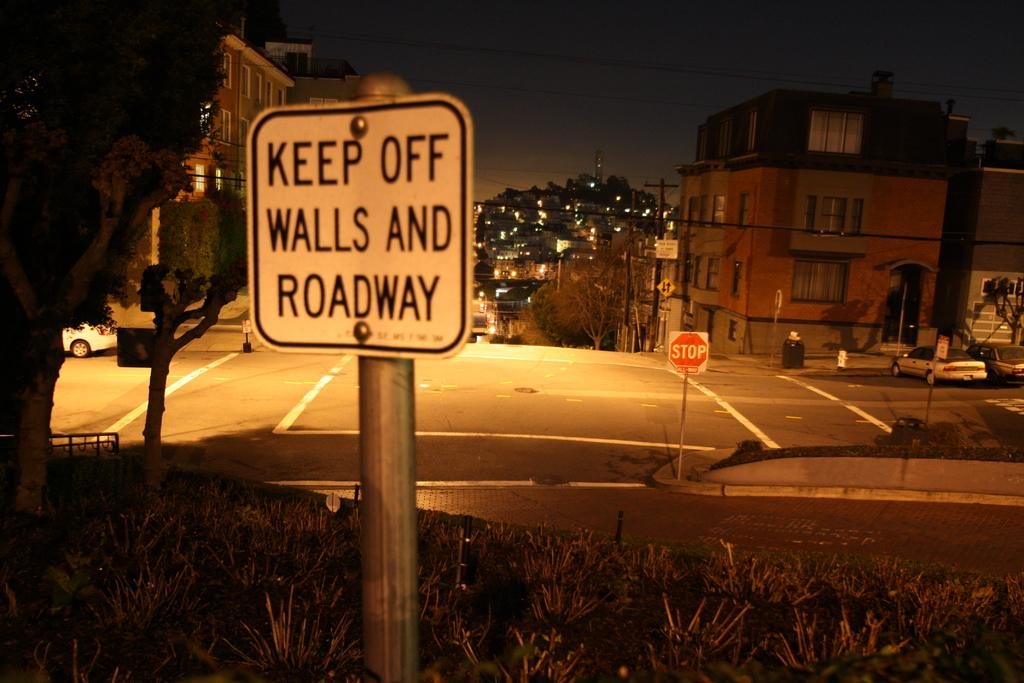<image>
Present a compact description of the photo's key features. A sign outside in the grass at night stating keep off the walls and roadway. 